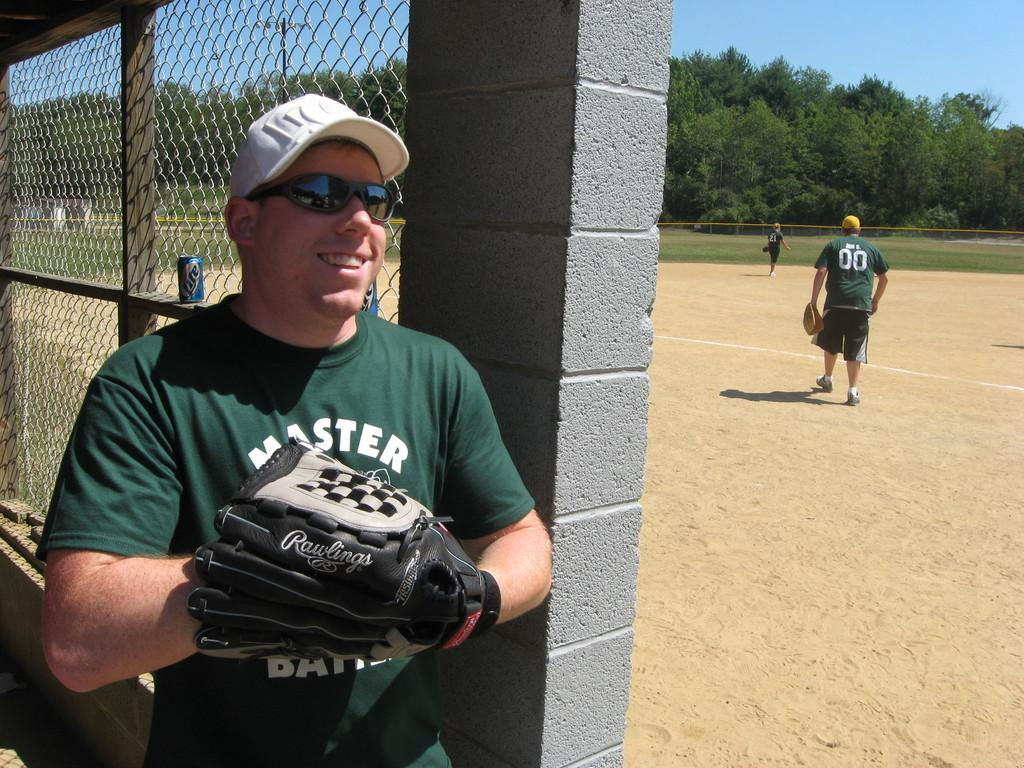<image>
Write a terse but informative summary of the picture. A man in a green shirt that says master holds up his baseball glove. 